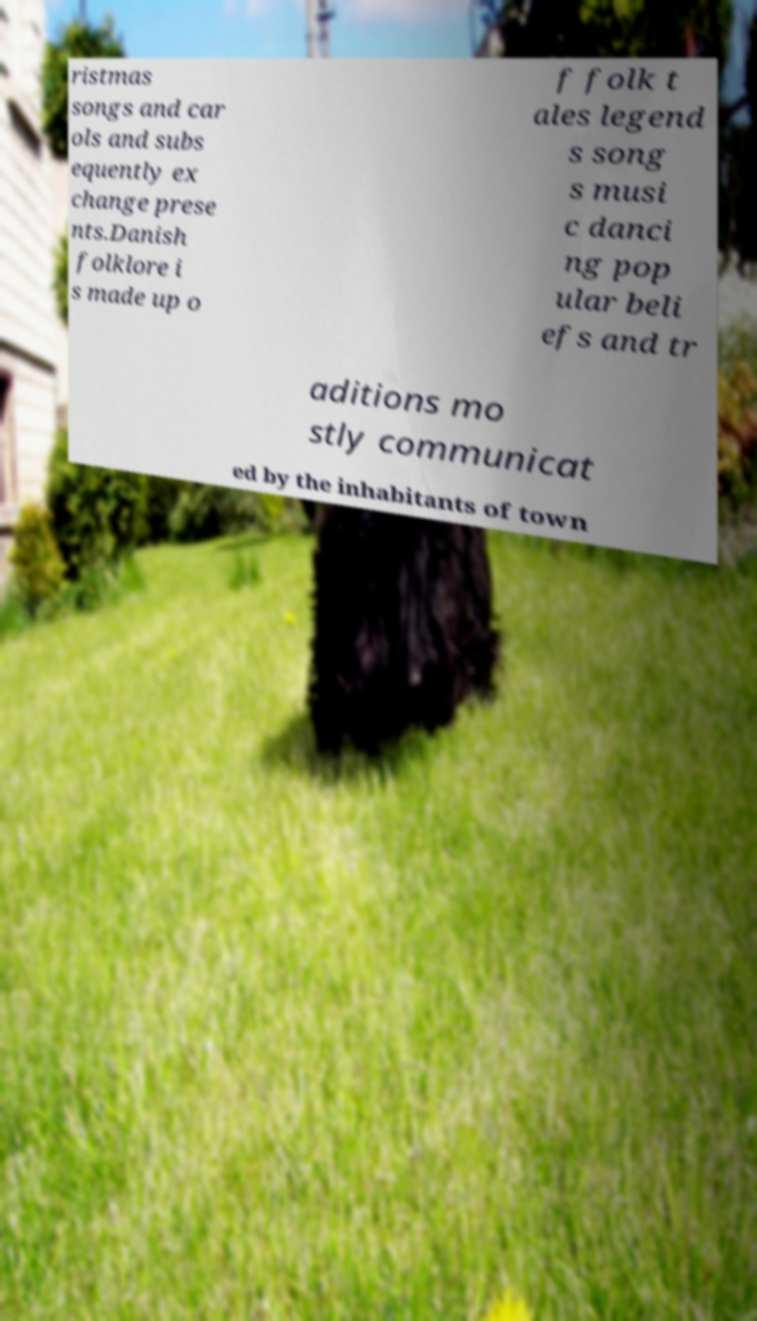Please identify and transcribe the text found in this image. ristmas songs and car ols and subs equently ex change prese nts.Danish folklore i s made up o f folk t ales legend s song s musi c danci ng pop ular beli efs and tr aditions mo stly communicat ed by the inhabitants of town 